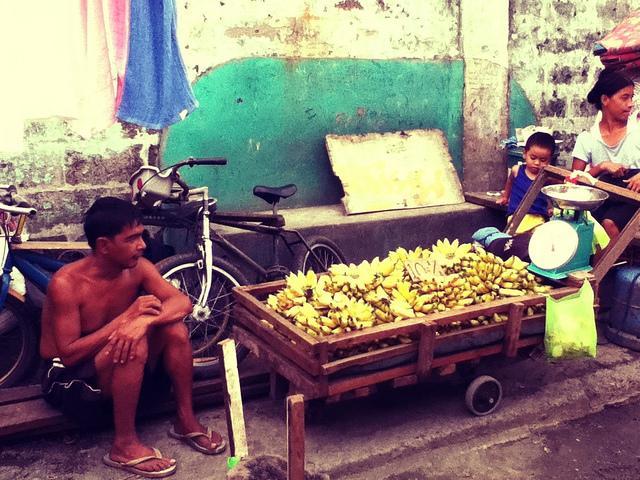Is this in the United States?
Be succinct. No. Does the boy on left have a shirt on?
Be succinct. No. What kind of fruit is in the cart?
Be succinct. Bananas. 